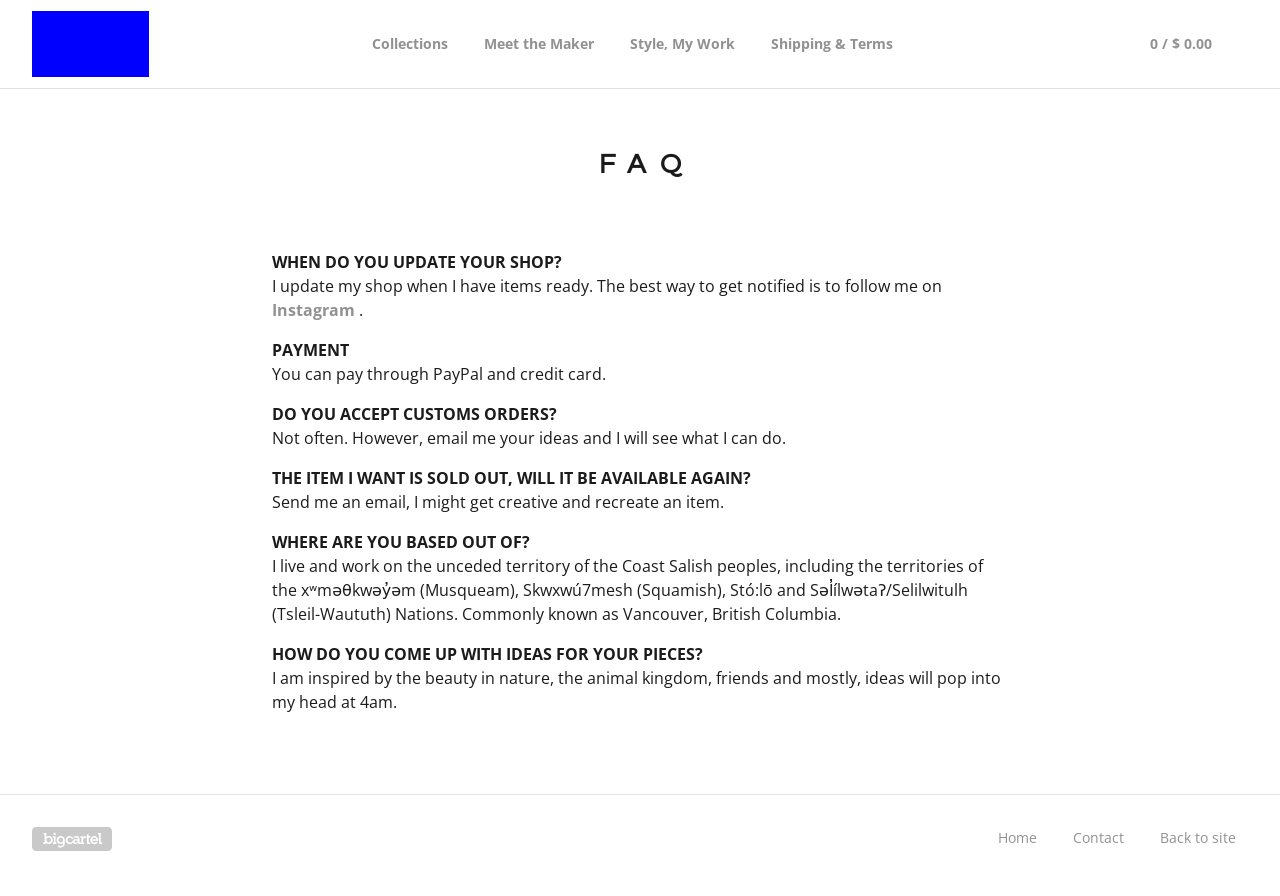How does the website manage to follow the theme and style as mentioned in the header of the FAQ page? The website follows its theme by using a minimalist design with a clean white background and black text which maintains a modern look while focusing on readability and usability. The theme is consistent across other elements such as the header and navigation bar, with uniform fonts and layout styles that contribute to a cohesive aesthetic. What kind of stylistic elements could be used to enhance this page further? Enhancements could include the use of subtle background colors or patterns to add depth, incorporating interactive elements such as hover effects on links for better user engagement, and perhaps adding iconography next to FAQ questions for visual interest. Additionally, integrating more dynamic elements such as collapsible sections for each FAQ could improve the user experience by making the page less cluttered and more navigable. 